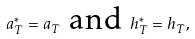Convert formula to latex. <formula><loc_0><loc_0><loc_500><loc_500>a _ { T } ^ { \ast } = a _ { T } \text { and } h _ { T } ^ { \ast } = h _ { T } ,</formula> 